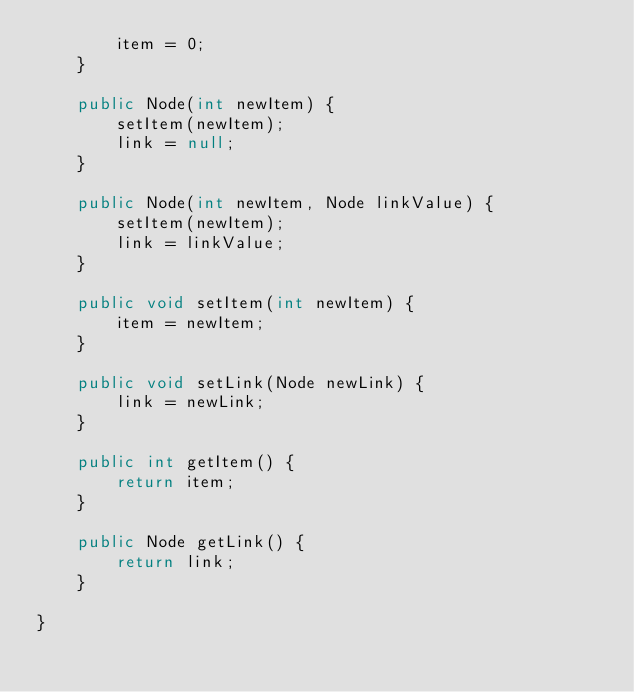Convert code to text. <code><loc_0><loc_0><loc_500><loc_500><_Java_>		item = 0;
	}

	public Node(int newItem) {
		setItem(newItem);
		link = null;
	}

	public Node(int newItem, Node linkValue) {
		setItem(newItem);
		link = linkValue;
	}

	public void setItem(int newItem) {
		item = newItem;
	}

	public void setLink(Node newLink) {
		link = newLink;
	}

	public int getItem() {
		return item;
	}

	public Node getLink() {
		return link;
	}

}
</code> 